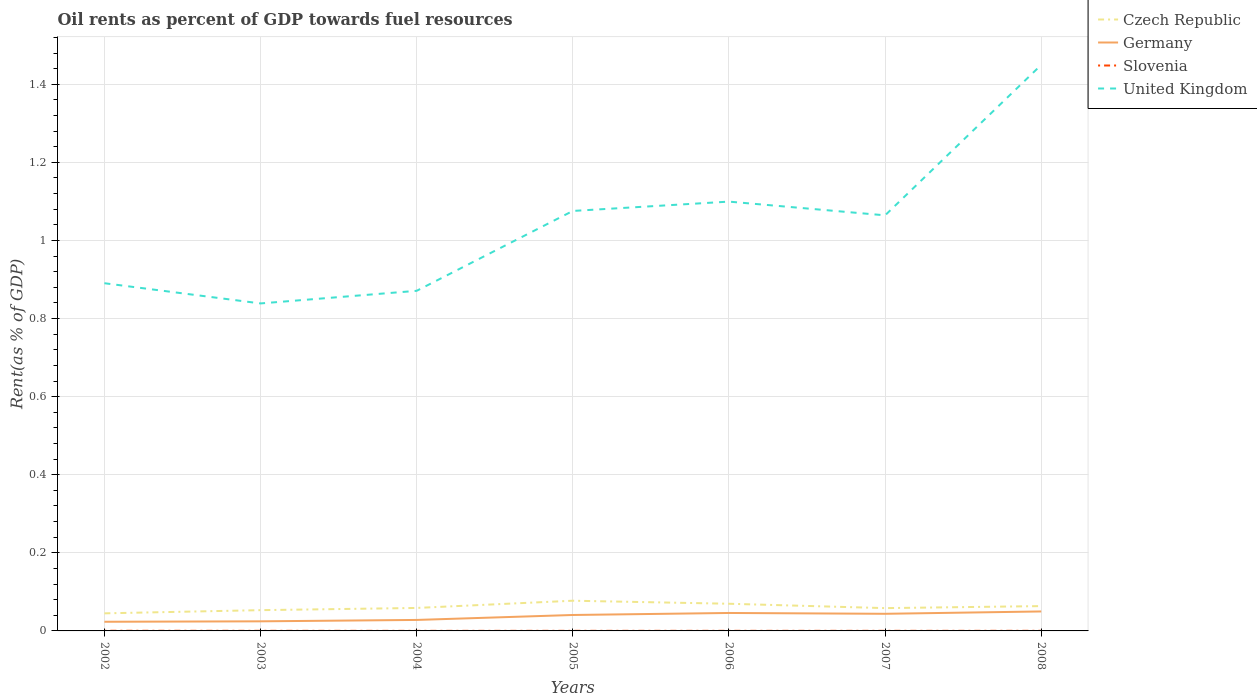How many different coloured lines are there?
Your answer should be very brief. 4. Across all years, what is the maximum oil rent in Czech Republic?
Keep it short and to the point. 0.05. In which year was the oil rent in United Kingdom maximum?
Offer a terse response. 2003. What is the total oil rent in Germany in the graph?
Ensure brevity in your answer.  -0.02. What is the difference between the highest and the second highest oil rent in United Kingdom?
Provide a short and direct response. 0.61. What is the difference between the highest and the lowest oil rent in Slovenia?
Your response must be concise. 3. Is the oil rent in Czech Republic strictly greater than the oil rent in Germany over the years?
Make the answer very short. No. How many lines are there?
Provide a short and direct response. 4. How many years are there in the graph?
Keep it short and to the point. 7. Are the values on the major ticks of Y-axis written in scientific E-notation?
Your answer should be compact. No. Does the graph contain any zero values?
Your response must be concise. No. Does the graph contain grids?
Give a very brief answer. Yes. What is the title of the graph?
Give a very brief answer. Oil rents as percent of GDP towards fuel resources. Does "Luxembourg" appear as one of the legend labels in the graph?
Offer a terse response. No. What is the label or title of the X-axis?
Keep it short and to the point. Years. What is the label or title of the Y-axis?
Give a very brief answer. Rent(as % of GDP). What is the Rent(as % of GDP) of Czech Republic in 2002?
Provide a short and direct response. 0.05. What is the Rent(as % of GDP) in Germany in 2002?
Provide a succinct answer. 0.02. What is the Rent(as % of GDP) of Slovenia in 2002?
Give a very brief answer. 0. What is the Rent(as % of GDP) in United Kingdom in 2002?
Ensure brevity in your answer.  0.89. What is the Rent(as % of GDP) of Czech Republic in 2003?
Give a very brief answer. 0.05. What is the Rent(as % of GDP) in Germany in 2003?
Give a very brief answer. 0.02. What is the Rent(as % of GDP) in Slovenia in 2003?
Provide a succinct answer. 0. What is the Rent(as % of GDP) of United Kingdom in 2003?
Your response must be concise. 0.84. What is the Rent(as % of GDP) in Czech Republic in 2004?
Provide a succinct answer. 0.06. What is the Rent(as % of GDP) in Germany in 2004?
Offer a terse response. 0.03. What is the Rent(as % of GDP) of Slovenia in 2004?
Offer a terse response. 0. What is the Rent(as % of GDP) of United Kingdom in 2004?
Your answer should be very brief. 0.87. What is the Rent(as % of GDP) of Czech Republic in 2005?
Offer a very short reply. 0.08. What is the Rent(as % of GDP) of Germany in 2005?
Offer a terse response. 0.04. What is the Rent(as % of GDP) in Slovenia in 2005?
Offer a very short reply. 0. What is the Rent(as % of GDP) of United Kingdom in 2005?
Make the answer very short. 1.08. What is the Rent(as % of GDP) in Czech Republic in 2006?
Ensure brevity in your answer.  0.07. What is the Rent(as % of GDP) in Germany in 2006?
Give a very brief answer. 0.05. What is the Rent(as % of GDP) of Slovenia in 2006?
Your response must be concise. 0. What is the Rent(as % of GDP) of United Kingdom in 2006?
Provide a short and direct response. 1.1. What is the Rent(as % of GDP) in Czech Republic in 2007?
Make the answer very short. 0.06. What is the Rent(as % of GDP) of Germany in 2007?
Ensure brevity in your answer.  0.04. What is the Rent(as % of GDP) in Slovenia in 2007?
Your answer should be compact. 0. What is the Rent(as % of GDP) in United Kingdom in 2007?
Your answer should be very brief. 1.06. What is the Rent(as % of GDP) of Czech Republic in 2008?
Your response must be concise. 0.06. What is the Rent(as % of GDP) in Germany in 2008?
Provide a short and direct response. 0.05. What is the Rent(as % of GDP) of Slovenia in 2008?
Provide a short and direct response. 0. What is the Rent(as % of GDP) of United Kingdom in 2008?
Make the answer very short. 1.45. Across all years, what is the maximum Rent(as % of GDP) of Czech Republic?
Keep it short and to the point. 0.08. Across all years, what is the maximum Rent(as % of GDP) of Germany?
Provide a short and direct response. 0.05. Across all years, what is the maximum Rent(as % of GDP) in Slovenia?
Offer a terse response. 0. Across all years, what is the maximum Rent(as % of GDP) in United Kingdom?
Your response must be concise. 1.45. Across all years, what is the minimum Rent(as % of GDP) of Czech Republic?
Your answer should be very brief. 0.05. Across all years, what is the minimum Rent(as % of GDP) of Germany?
Offer a very short reply. 0.02. Across all years, what is the minimum Rent(as % of GDP) of Slovenia?
Ensure brevity in your answer.  0. Across all years, what is the minimum Rent(as % of GDP) of United Kingdom?
Your response must be concise. 0.84. What is the total Rent(as % of GDP) in Czech Republic in the graph?
Provide a succinct answer. 0.43. What is the total Rent(as % of GDP) of Germany in the graph?
Give a very brief answer. 0.26. What is the total Rent(as % of GDP) in Slovenia in the graph?
Your response must be concise. 0. What is the total Rent(as % of GDP) of United Kingdom in the graph?
Ensure brevity in your answer.  7.29. What is the difference between the Rent(as % of GDP) of Czech Republic in 2002 and that in 2003?
Offer a terse response. -0.01. What is the difference between the Rent(as % of GDP) of Germany in 2002 and that in 2003?
Offer a very short reply. -0. What is the difference between the Rent(as % of GDP) in United Kingdom in 2002 and that in 2003?
Your response must be concise. 0.05. What is the difference between the Rent(as % of GDP) in Czech Republic in 2002 and that in 2004?
Offer a terse response. -0.01. What is the difference between the Rent(as % of GDP) in Germany in 2002 and that in 2004?
Give a very brief answer. -0. What is the difference between the Rent(as % of GDP) in Slovenia in 2002 and that in 2004?
Give a very brief answer. 0. What is the difference between the Rent(as % of GDP) of United Kingdom in 2002 and that in 2004?
Keep it short and to the point. 0.02. What is the difference between the Rent(as % of GDP) of Czech Republic in 2002 and that in 2005?
Keep it short and to the point. -0.03. What is the difference between the Rent(as % of GDP) of Germany in 2002 and that in 2005?
Ensure brevity in your answer.  -0.02. What is the difference between the Rent(as % of GDP) of Slovenia in 2002 and that in 2005?
Keep it short and to the point. 0. What is the difference between the Rent(as % of GDP) of United Kingdom in 2002 and that in 2005?
Your response must be concise. -0.19. What is the difference between the Rent(as % of GDP) in Czech Republic in 2002 and that in 2006?
Ensure brevity in your answer.  -0.02. What is the difference between the Rent(as % of GDP) of Germany in 2002 and that in 2006?
Offer a very short reply. -0.02. What is the difference between the Rent(as % of GDP) of United Kingdom in 2002 and that in 2006?
Your answer should be compact. -0.21. What is the difference between the Rent(as % of GDP) of Czech Republic in 2002 and that in 2007?
Offer a terse response. -0.01. What is the difference between the Rent(as % of GDP) of Germany in 2002 and that in 2007?
Offer a very short reply. -0.02. What is the difference between the Rent(as % of GDP) in United Kingdom in 2002 and that in 2007?
Your answer should be compact. -0.17. What is the difference between the Rent(as % of GDP) in Czech Republic in 2002 and that in 2008?
Offer a terse response. -0.02. What is the difference between the Rent(as % of GDP) in Germany in 2002 and that in 2008?
Ensure brevity in your answer.  -0.03. What is the difference between the Rent(as % of GDP) in United Kingdom in 2002 and that in 2008?
Offer a very short reply. -0.56. What is the difference between the Rent(as % of GDP) of Czech Republic in 2003 and that in 2004?
Offer a very short reply. -0.01. What is the difference between the Rent(as % of GDP) in Germany in 2003 and that in 2004?
Your answer should be very brief. -0. What is the difference between the Rent(as % of GDP) of United Kingdom in 2003 and that in 2004?
Offer a terse response. -0.03. What is the difference between the Rent(as % of GDP) of Czech Republic in 2003 and that in 2005?
Your answer should be compact. -0.02. What is the difference between the Rent(as % of GDP) of Germany in 2003 and that in 2005?
Ensure brevity in your answer.  -0.02. What is the difference between the Rent(as % of GDP) in United Kingdom in 2003 and that in 2005?
Provide a short and direct response. -0.24. What is the difference between the Rent(as % of GDP) of Czech Republic in 2003 and that in 2006?
Provide a short and direct response. -0.02. What is the difference between the Rent(as % of GDP) in Germany in 2003 and that in 2006?
Make the answer very short. -0.02. What is the difference between the Rent(as % of GDP) of Slovenia in 2003 and that in 2006?
Your answer should be compact. 0. What is the difference between the Rent(as % of GDP) of United Kingdom in 2003 and that in 2006?
Keep it short and to the point. -0.26. What is the difference between the Rent(as % of GDP) of Czech Republic in 2003 and that in 2007?
Provide a succinct answer. -0.01. What is the difference between the Rent(as % of GDP) in Germany in 2003 and that in 2007?
Provide a short and direct response. -0.02. What is the difference between the Rent(as % of GDP) of United Kingdom in 2003 and that in 2007?
Ensure brevity in your answer.  -0.23. What is the difference between the Rent(as % of GDP) of Czech Republic in 2003 and that in 2008?
Your answer should be very brief. -0.01. What is the difference between the Rent(as % of GDP) in Germany in 2003 and that in 2008?
Keep it short and to the point. -0.03. What is the difference between the Rent(as % of GDP) of United Kingdom in 2003 and that in 2008?
Ensure brevity in your answer.  -0.61. What is the difference between the Rent(as % of GDP) of Czech Republic in 2004 and that in 2005?
Provide a succinct answer. -0.02. What is the difference between the Rent(as % of GDP) of Germany in 2004 and that in 2005?
Make the answer very short. -0.01. What is the difference between the Rent(as % of GDP) in United Kingdom in 2004 and that in 2005?
Give a very brief answer. -0.2. What is the difference between the Rent(as % of GDP) of Czech Republic in 2004 and that in 2006?
Make the answer very short. -0.01. What is the difference between the Rent(as % of GDP) of Germany in 2004 and that in 2006?
Offer a terse response. -0.02. What is the difference between the Rent(as % of GDP) in Slovenia in 2004 and that in 2006?
Keep it short and to the point. -0. What is the difference between the Rent(as % of GDP) in United Kingdom in 2004 and that in 2006?
Make the answer very short. -0.23. What is the difference between the Rent(as % of GDP) in Germany in 2004 and that in 2007?
Ensure brevity in your answer.  -0.02. What is the difference between the Rent(as % of GDP) of Slovenia in 2004 and that in 2007?
Offer a very short reply. -0. What is the difference between the Rent(as % of GDP) of United Kingdom in 2004 and that in 2007?
Provide a short and direct response. -0.19. What is the difference between the Rent(as % of GDP) in Czech Republic in 2004 and that in 2008?
Ensure brevity in your answer.  -0. What is the difference between the Rent(as % of GDP) of Germany in 2004 and that in 2008?
Provide a short and direct response. -0.02. What is the difference between the Rent(as % of GDP) in Slovenia in 2004 and that in 2008?
Your response must be concise. -0. What is the difference between the Rent(as % of GDP) in United Kingdom in 2004 and that in 2008?
Your answer should be very brief. -0.58. What is the difference between the Rent(as % of GDP) in Czech Republic in 2005 and that in 2006?
Give a very brief answer. 0.01. What is the difference between the Rent(as % of GDP) of Germany in 2005 and that in 2006?
Offer a very short reply. -0.01. What is the difference between the Rent(as % of GDP) of Slovenia in 2005 and that in 2006?
Offer a terse response. -0. What is the difference between the Rent(as % of GDP) in United Kingdom in 2005 and that in 2006?
Your answer should be very brief. -0.02. What is the difference between the Rent(as % of GDP) in Czech Republic in 2005 and that in 2007?
Offer a very short reply. 0.02. What is the difference between the Rent(as % of GDP) of Germany in 2005 and that in 2007?
Provide a succinct answer. -0. What is the difference between the Rent(as % of GDP) in Slovenia in 2005 and that in 2007?
Offer a very short reply. -0. What is the difference between the Rent(as % of GDP) of United Kingdom in 2005 and that in 2007?
Your response must be concise. 0.01. What is the difference between the Rent(as % of GDP) of Czech Republic in 2005 and that in 2008?
Give a very brief answer. 0.01. What is the difference between the Rent(as % of GDP) in Germany in 2005 and that in 2008?
Give a very brief answer. -0.01. What is the difference between the Rent(as % of GDP) in United Kingdom in 2005 and that in 2008?
Your response must be concise. -0.37. What is the difference between the Rent(as % of GDP) of Czech Republic in 2006 and that in 2007?
Keep it short and to the point. 0.01. What is the difference between the Rent(as % of GDP) of Germany in 2006 and that in 2007?
Ensure brevity in your answer.  0. What is the difference between the Rent(as % of GDP) of United Kingdom in 2006 and that in 2007?
Make the answer very short. 0.04. What is the difference between the Rent(as % of GDP) of Czech Republic in 2006 and that in 2008?
Ensure brevity in your answer.  0.01. What is the difference between the Rent(as % of GDP) of Germany in 2006 and that in 2008?
Your response must be concise. -0. What is the difference between the Rent(as % of GDP) of United Kingdom in 2006 and that in 2008?
Give a very brief answer. -0.35. What is the difference between the Rent(as % of GDP) of Czech Republic in 2007 and that in 2008?
Your response must be concise. -0.01. What is the difference between the Rent(as % of GDP) in Germany in 2007 and that in 2008?
Offer a very short reply. -0.01. What is the difference between the Rent(as % of GDP) in United Kingdom in 2007 and that in 2008?
Make the answer very short. -0.39. What is the difference between the Rent(as % of GDP) of Czech Republic in 2002 and the Rent(as % of GDP) of Germany in 2003?
Your response must be concise. 0.02. What is the difference between the Rent(as % of GDP) of Czech Republic in 2002 and the Rent(as % of GDP) of Slovenia in 2003?
Give a very brief answer. 0.04. What is the difference between the Rent(as % of GDP) of Czech Republic in 2002 and the Rent(as % of GDP) of United Kingdom in 2003?
Give a very brief answer. -0.79. What is the difference between the Rent(as % of GDP) in Germany in 2002 and the Rent(as % of GDP) in Slovenia in 2003?
Your response must be concise. 0.02. What is the difference between the Rent(as % of GDP) in Germany in 2002 and the Rent(as % of GDP) in United Kingdom in 2003?
Ensure brevity in your answer.  -0.82. What is the difference between the Rent(as % of GDP) in Slovenia in 2002 and the Rent(as % of GDP) in United Kingdom in 2003?
Keep it short and to the point. -0.84. What is the difference between the Rent(as % of GDP) of Czech Republic in 2002 and the Rent(as % of GDP) of Germany in 2004?
Your response must be concise. 0.02. What is the difference between the Rent(as % of GDP) in Czech Republic in 2002 and the Rent(as % of GDP) in Slovenia in 2004?
Make the answer very short. 0.04. What is the difference between the Rent(as % of GDP) in Czech Republic in 2002 and the Rent(as % of GDP) in United Kingdom in 2004?
Offer a terse response. -0.83. What is the difference between the Rent(as % of GDP) of Germany in 2002 and the Rent(as % of GDP) of Slovenia in 2004?
Provide a short and direct response. 0.02. What is the difference between the Rent(as % of GDP) of Germany in 2002 and the Rent(as % of GDP) of United Kingdom in 2004?
Keep it short and to the point. -0.85. What is the difference between the Rent(as % of GDP) of Slovenia in 2002 and the Rent(as % of GDP) of United Kingdom in 2004?
Offer a terse response. -0.87. What is the difference between the Rent(as % of GDP) in Czech Republic in 2002 and the Rent(as % of GDP) in Germany in 2005?
Offer a terse response. 0. What is the difference between the Rent(as % of GDP) in Czech Republic in 2002 and the Rent(as % of GDP) in Slovenia in 2005?
Keep it short and to the point. 0.04. What is the difference between the Rent(as % of GDP) in Czech Republic in 2002 and the Rent(as % of GDP) in United Kingdom in 2005?
Provide a succinct answer. -1.03. What is the difference between the Rent(as % of GDP) in Germany in 2002 and the Rent(as % of GDP) in Slovenia in 2005?
Your response must be concise. 0.02. What is the difference between the Rent(as % of GDP) of Germany in 2002 and the Rent(as % of GDP) of United Kingdom in 2005?
Keep it short and to the point. -1.05. What is the difference between the Rent(as % of GDP) of Slovenia in 2002 and the Rent(as % of GDP) of United Kingdom in 2005?
Provide a short and direct response. -1.08. What is the difference between the Rent(as % of GDP) of Czech Republic in 2002 and the Rent(as % of GDP) of Germany in 2006?
Your answer should be compact. -0. What is the difference between the Rent(as % of GDP) in Czech Republic in 2002 and the Rent(as % of GDP) in Slovenia in 2006?
Give a very brief answer. 0.04. What is the difference between the Rent(as % of GDP) in Czech Republic in 2002 and the Rent(as % of GDP) in United Kingdom in 2006?
Keep it short and to the point. -1.05. What is the difference between the Rent(as % of GDP) in Germany in 2002 and the Rent(as % of GDP) in Slovenia in 2006?
Offer a very short reply. 0.02. What is the difference between the Rent(as % of GDP) of Germany in 2002 and the Rent(as % of GDP) of United Kingdom in 2006?
Offer a very short reply. -1.08. What is the difference between the Rent(as % of GDP) in Slovenia in 2002 and the Rent(as % of GDP) in United Kingdom in 2006?
Your answer should be very brief. -1.1. What is the difference between the Rent(as % of GDP) in Czech Republic in 2002 and the Rent(as % of GDP) in Germany in 2007?
Make the answer very short. 0. What is the difference between the Rent(as % of GDP) of Czech Republic in 2002 and the Rent(as % of GDP) of Slovenia in 2007?
Make the answer very short. 0.04. What is the difference between the Rent(as % of GDP) of Czech Republic in 2002 and the Rent(as % of GDP) of United Kingdom in 2007?
Provide a short and direct response. -1.02. What is the difference between the Rent(as % of GDP) in Germany in 2002 and the Rent(as % of GDP) in Slovenia in 2007?
Keep it short and to the point. 0.02. What is the difference between the Rent(as % of GDP) in Germany in 2002 and the Rent(as % of GDP) in United Kingdom in 2007?
Ensure brevity in your answer.  -1.04. What is the difference between the Rent(as % of GDP) in Slovenia in 2002 and the Rent(as % of GDP) in United Kingdom in 2007?
Offer a terse response. -1.06. What is the difference between the Rent(as % of GDP) in Czech Republic in 2002 and the Rent(as % of GDP) in Germany in 2008?
Your answer should be very brief. -0. What is the difference between the Rent(as % of GDP) in Czech Republic in 2002 and the Rent(as % of GDP) in Slovenia in 2008?
Ensure brevity in your answer.  0.04. What is the difference between the Rent(as % of GDP) in Czech Republic in 2002 and the Rent(as % of GDP) in United Kingdom in 2008?
Your answer should be compact. -1.4. What is the difference between the Rent(as % of GDP) in Germany in 2002 and the Rent(as % of GDP) in Slovenia in 2008?
Your answer should be very brief. 0.02. What is the difference between the Rent(as % of GDP) in Germany in 2002 and the Rent(as % of GDP) in United Kingdom in 2008?
Give a very brief answer. -1.43. What is the difference between the Rent(as % of GDP) of Slovenia in 2002 and the Rent(as % of GDP) of United Kingdom in 2008?
Ensure brevity in your answer.  -1.45. What is the difference between the Rent(as % of GDP) in Czech Republic in 2003 and the Rent(as % of GDP) in Germany in 2004?
Your answer should be very brief. 0.03. What is the difference between the Rent(as % of GDP) of Czech Republic in 2003 and the Rent(as % of GDP) of Slovenia in 2004?
Provide a succinct answer. 0.05. What is the difference between the Rent(as % of GDP) in Czech Republic in 2003 and the Rent(as % of GDP) in United Kingdom in 2004?
Your answer should be compact. -0.82. What is the difference between the Rent(as % of GDP) in Germany in 2003 and the Rent(as % of GDP) in Slovenia in 2004?
Provide a succinct answer. 0.02. What is the difference between the Rent(as % of GDP) of Germany in 2003 and the Rent(as % of GDP) of United Kingdom in 2004?
Your answer should be compact. -0.85. What is the difference between the Rent(as % of GDP) of Slovenia in 2003 and the Rent(as % of GDP) of United Kingdom in 2004?
Your answer should be compact. -0.87. What is the difference between the Rent(as % of GDP) in Czech Republic in 2003 and the Rent(as % of GDP) in Germany in 2005?
Offer a very short reply. 0.01. What is the difference between the Rent(as % of GDP) of Czech Republic in 2003 and the Rent(as % of GDP) of Slovenia in 2005?
Ensure brevity in your answer.  0.05. What is the difference between the Rent(as % of GDP) of Czech Republic in 2003 and the Rent(as % of GDP) of United Kingdom in 2005?
Your answer should be compact. -1.02. What is the difference between the Rent(as % of GDP) in Germany in 2003 and the Rent(as % of GDP) in Slovenia in 2005?
Your answer should be very brief. 0.02. What is the difference between the Rent(as % of GDP) in Germany in 2003 and the Rent(as % of GDP) in United Kingdom in 2005?
Make the answer very short. -1.05. What is the difference between the Rent(as % of GDP) in Slovenia in 2003 and the Rent(as % of GDP) in United Kingdom in 2005?
Keep it short and to the point. -1.08. What is the difference between the Rent(as % of GDP) of Czech Republic in 2003 and the Rent(as % of GDP) of Germany in 2006?
Your answer should be compact. 0.01. What is the difference between the Rent(as % of GDP) in Czech Republic in 2003 and the Rent(as % of GDP) in Slovenia in 2006?
Ensure brevity in your answer.  0.05. What is the difference between the Rent(as % of GDP) of Czech Republic in 2003 and the Rent(as % of GDP) of United Kingdom in 2006?
Provide a short and direct response. -1.05. What is the difference between the Rent(as % of GDP) in Germany in 2003 and the Rent(as % of GDP) in Slovenia in 2006?
Offer a terse response. 0.02. What is the difference between the Rent(as % of GDP) in Germany in 2003 and the Rent(as % of GDP) in United Kingdom in 2006?
Your answer should be very brief. -1.07. What is the difference between the Rent(as % of GDP) in Slovenia in 2003 and the Rent(as % of GDP) in United Kingdom in 2006?
Give a very brief answer. -1.1. What is the difference between the Rent(as % of GDP) in Czech Republic in 2003 and the Rent(as % of GDP) in Germany in 2007?
Provide a succinct answer. 0.01. What is the difference between the Rent(as % of GDP) in Czech Republic in 2003 and the Rent(as % of GDP) in Slovenia in 2007?
Offer a very short reply. 0.05. What is the difference between the Rent(as % of GDP) of Czech Republic in 2003 and the Rent(as % of GDP) of United Kingdom in 2007?
Your answer should be very brief. -1.01. What is the difference between the Rent(as % of GDP) in Germany in 2003 and the Rent(as % of GDP) in Slovenia in 2007?
Your answer should be compact. 0.02. What is the difference between the Rent(as % of GDP) in Germany in 2003 and the Rent(as % of GDP) in United Kingdom in 2007?
Your response must be concise. -1.04. What is the difference between the Rent(as % of GDP) in Slovenia in 2003 and the Rent(as % of GDP) in United Kingdom in 2007?
Your response must be concise. -1.06. What is the difference between the Rent(as % of GDP) in Czech Republic in 2003 and the Rent(as % of GDP) in Germany in 2008?
Provide a succinct answer. 0. What is the difference between the Rent(as % of GDP) of Czech Republic in 2003 and the Rent(as % of GDP) of Slovenia in 2008?
Provide a short and direct response. 0.05. What is the difference between the Rent(as % of GDP) in Czech Republic in 2003 and the Rent(as % of GDP) in United Kingdom in 2008?
Offer a terse response. -1.4. What is the difference between the Rent(as % of GDP) in Germany in 2003 and the Rent(as % of GDP) in Slovenia in 2008?
Your answer should be compact. 0.02. What is the difference between the Rent(as % of GDP) of Germany in 2003 and the Rent(as % of GDP) of United Kingdom in 2008?
Offer a terse response. -1.43. What is the difference between the Rent(as % of GDP) in Slovenia in 2003 and the Rent(as % of GDP) in United Kingdom in 2008?
Give a very brief answer. -1.45. What is the difference between the Rent(as % of GDP) of Czech Republic in 2004 and the Rent(as % of GDP) of Germany in 2005?
Offer a terse response. 0.02. What is the difference between the Rent(as % of GDP) of Czech Republic in 2004 and the Rent(as % of GDP) of Slovenia in 2005?
Ensure brevity in your answer.  0.06. What is the difference between the Rent(as % of GDP) in Czech Republic in 2004 and the Rent(as % of GDP) in United Kingdom in 2005?
Keep it short and to the point. -1.02. What is the difference between the Rent(as % of GDP) of Germany in 2004 and the Rent(as % of GDP) of Slovenia in 2005?
Ensure brevity in your answer.  0.03. What is the difference between the Rent(as % of GDP) of Germany in 2004 and the Rent(as % of GDP) of United Kingdom in 2005?
Ensure brevity in your answer.  -1.05. What is the difference between the Rent(as % of GDP) of Slovenia in 2004 and the Rent(as % of GDP) of United Kingdom in 2005?
Provide a short and direct response. -1.08. What is the difference between the Rent(as % of GDP) of Czech Republic in 2004 and the Rent(as % of GDP) of Germany in 2006?
Offer a terse response. 0.01. What is the difference between the Rent(as % of GDP) of Czech Republic in 2004 and the Rent(as % of GDP) of Slovenia in 2006?
Ensure brevity in your answer.  0.06. What is the difference between the Rent(as % of GDP) of Czech Republic in 2004 and the Rent(as % of GDP) of United Kingdom in 2006?
Offer a terse response. -1.04. What is the difference between the Rent(as % of GDP) of Germany in 2004 and the Rent(as % of GDP) of Slovenia in 2006?
Ensure brevity in your answer.  0.03. What is the difference between the Rent(as % of GDP) in Germany in 2004 and the Rent(as % of GDP) in United Kingdom in 2006?
Provide a short and direct response. -1.07. What is the difference between the Rent(as % of GDP) of Slovenia in 2004 and the Rent(as % of GDP) of United Kingdom in 2006?
Provide a short and direct response. -1.1. What is the difference between the Rent(as % of GDP) of Czech Republic in 2004 and the Rent(as % of GDP) of Germany in 2007?
Offer a terse response. 0.01. What is the difference between the Rent(as % of GDP) of Czech Republic in 2004 and the Rent(as % of GDP) of Slovenia in 2007?
Provide a succinct answer. 0.06. What is the difference between the Rent(as % of GDP) in Czech Republic in 2004 and the Rent(as % of GDP) in United Kingdom in 2007?
Offer a terse response. -1.01. What is the difference between the Rent(as % of GDP) in Germany in 2004 and the Rent(as % of GDP) in Slovenia in 2007?
Give a very brief answer. 0.03. What is the difference between the Rent(as % of GDP) in Germany in 2004 and the Rent(as % of GDP) in United Kingdom in 2007?
Offer a terse response. -1.04. What is the difference between the Rent(as % of GDP) of Slovenia in 2004 and the Rent(as % of GDP) of United Kingdom in 2007?
Make the answer very short. -1.06. What is the difference between the Rent(as % of GDP) of Czech Republic in 2004 and the Rent(as % of GDP) of Germany in 2008?
Offer a very short reply. 0.01. What is the difference between the Rent(as % of GDP) of Czech Republic in 2004 and the Rent(as % of GDP) of Slovenia in 2008?
Offer a very short reply. 0.06. What is the difference between the Rent(as % of GDP) in Czech Republic in 2004 and the Rent(as % of GDP) in United Kingdom in 2008?
Offer a very short reply. -1.39. What is the difference between the Rent(as % of GDP) of Germany in 2004 and the Rent(as % of GDP) of Slovenia in 2008?
Offer a terse response. 0.03. What is the difference between the Rent(as % of GDP) of Germany in 2004 and the Rent(as % of GDP) of United Kingdom in 2008?
Your answer should be very brief. -1.42. What is the difference between the Rent(as % of GDP) of Slovenia in 2004 and the Rent(as % of GDP) of United Kingdom in 2008?
Offer a terse response. -1.45. What is the difference between the Rent(as % of GDP) in Czech Republic in 2005 and the Rent(as % of GDP) in Germany in 2006?
Your answer should be very brief. 0.03. What is the difference between the Rent(as % of GDP) of Czech Republic in 2005 and the Rent(as % of GDP) of Slovenia in 2006?
Your response must be concise. 0.08. What is the difference between the Rent(as % of GDP) in Czech Republic in 2005 and the Rent(as % of GDP) in United Kingdom in 2006?
Your answer should be compact. -1.02. What is the difference between the Rent(as % of GDP) of Germany in 2005 and the Rent(as % of GDP) of Slovenia in 2006?
Keep it short and to the point. 0.04. What is the difference between the Rent(as % of GDP) of Germany in 2005 and the Rent(as % of GDP) of United Kingdom in 2006?
Make the answer very short. -1.06. What is the difference between the Rent(as % of GDP) in Slovenia in 2005 and the Rent(as % of GDP) in United Kingdom in 2006?
Provide a short and direct response. -1.1. What is the difference between the Rent(as % of GDP) of Czech Republic in 2005 and the Rent(as % of GDP) of Germany in 2007?
Offer a terse response. 0.03. What is the difference between the Rent(as % of GDP) in Czech Republic in 2005 and the Rent(as % of GDP) in Slovenia in 2007?
Provide a short and direct response. 0.08. What is the difference between the Rent(as % of GDP) in Czech Republic in 2005 and the Rent(as % of GDP) in United Kingdom in 2007?
Your answer should be compact. -0.99. What is the difference between the Rent(as % of GDP) of Germany in 2005 and the Rent(as % of GDP) of Slovenia in 2007?
Ensure brevity in your answer.  0.04. What is the difference between the Rent(as % of GDP) in Germany in 2005 and the Rent(as % of GDP) in United Kingdom in 2007?
Provide a succinct answer. -1.02. What is the difference between the Rent(as % of GDP) in Slovenia in 2005 and the Rent(as % of GDP) in United Kingdom in 2007?
Provide a short and direct response. -1.06. What is the difference between the Rent(as % of GDP) of Czech Republic in 2005 and the Rent(as % of GDP) of Germany in 2008?
Provide a short and direct response. 0.03. What is the difference between the Rent(as % of GDP) in Czech Republic in 2005 and the Rent(as % of GDP) in Slovenia in 2008?
Offer a terse response. 0.08. What is the difference between the Rent(as % of GDP) of Czech Republic in 2005 and the Rent(as % of GDP) of United Kingdom in 2008?
Keep it short and to the point. -1.37. What is the difference between the Rent(as % of GDP) of Germany in 2005 and the Rent(as % of GDP) of Slovenia in 2008?
Offer a terse response. 0.04. What is the difference between the Rent(as % of GDP) of Germany in 2005 and the Rent(as % of GDP) of United Kingdom in 2008?
Give a very brief answer. -1.41. What is the difference between the Rent(as % of GDP) in Slovenia in 2005 and the Rent(as % of GDP) in United Kingdom in 2008?
Provide a succinct answer. -1.45. What is the difference between the Rent(as % of GDP) in Czech Republic in 2006 and the Rent(as % of GDP) in Germany in 2007?
Ensure brevity in your answer.  0.03. What is the difference between the Rent(as % of GDP) in Czech Republic in 2006 and the Rent(as % of GDP) in Slovenia in 2007?
Your response must be concise. 0.07. What is the difference between the Rent(as % of GDP) in Czech Republic in 2006 and the Rent(as % of GDP) in United Kingdom in 2007?
Your response must be concise. -0.99. What is the difference between the Rent(as % of GDP) in Germany in 2006 and the Rent(as % of GDP) in Slovenia in 2007?
Keep it short and to the point. 0.05. What is the difference between the Rent(as % of GDP) of Germany in 2006 and the Rent(as % of GDP) of United Kingdom in 2007?
Provide a succinct answer. -1.02. What is the difference between the Rent(as % of GDP) in Slovenia in 2006 and the Rent(as % of GDP) in United Kingdom in 2007?
Keep it short and to the point. -1.06. What is the difference between the Rent(as % of GDP) in Czech Republic in 2006 and the Rent(as % of GDP) in Germany in 2008?
Your answer should be compact. 0.02. What is the difference between the Rent(as % of GDP) of Czech Republic in 2006 and the Rent(as % of GDP) of Slovenia in 2008?
Make the answer very short. 0.07. What is the difference between the Rent(as % of GDP) in Czech Republic in 2006 and the Rent(as % of GDP) in United Kingdom in 2008?
Your answer should be very brief. -1.38. What is the difference between the Rent(as % of GDP) of Germany in 2006 and the Rent(as % of GDP) of Slovenia in 2008?
Ensure brevity in your answer.  0.05. What is the difference between the Rent(as % of GDP) in Germany in 2006 and the Rent(as % of GDP) in United Kingdom in 2008?
Keep it short and to the point. -1.4. What is the difference between the Rent(as % of GDP) of Slovenia in 2006 and the Rent(as % of GDP) of United Kingdom in 2008?
Your answer should be very brief. -1.45. What is the difference between the Rent(as % of GDP) in Czech Republic in 2007 and the Rent(as % of GDP) in Germany in 2008?
Offer a terse response. 0.01. What is the difference between the Rent(as % of GDP) of Czech Republic in 2007 and the Rent(as % of GDP) of Slovenia in 2008?
Keep it short and to the point. 0.06. What is the difference between the Rent(as % of GDP) of Czech Republic in 2007 and the Rent(as % of GDP) of United Kingdom in 2008?
Offer a very short reply. -1.39. What is the difference between the Rent(as % of GDP) of Germany in 2007 and the Rent(as % of GDP) of Slovenia in 2008?
Provide a short and direct response. 0.04. What is the difference between the Rent(as % of GDP) of Germany in 2007 and the Rent(as % of GDP) of United Kingdom in 2008?
Your response must be concise. -1.41. What is the difference between the Rent(as % of GDP) in Slovenia in 2007 and the Rent(as % of GDP) in United Kingdom in 2008?
Provide a succinct answer. -1.45. What is the average Rent(as % of GDP) in Czech Republic per year?
Your answer should be very brief. 0.06. What is the average Rent(as % of GDP) of Germany per year?
Your answer should be compact. 0.04. What is the average Rent(as % of GDP) of Slovenia per year?
Give a very brief answer. 0. What is the average Rent(as % of GDP) of United Kingdom per year?
Your response must be concise. 1.04. In the year 2002, what is the difference between the Rent(as % of GDP) in Czech Republic and Rent(as % of GDP) in Germany?
Offer a very short reply. 0.02. In the year 2002, what is the difference between the Rent(as % of GDP) in Czech Republic and Rent(as % of GDP) in Slovenia?
Your answer should be very brief. 0.04. In the year 2002, what is the difference between the Rent(as % of GDP) in Czech Republic and Rent(as % of GDP) in United Kingdom?
Provide a succinct answer. -0.85. In the year 2002, what is the difference between the Rent(as % of GDP) in Germany and Rent(as % of GDP) in Slovenia?
Provide a short and direct response. 0.02. In the year 2002, what is the difference between the Rent(as % of GDP) in Germany and Rent(as % of GDP) in United Kingdom?
Your response must be concise. -0.87. In the year 2002, what is the difference between the Rent(as % of GDP) of Slovenia and Rent(as % of GDP) of United Kingdom?
Give a very brief answer. -0.89. In the year 2003, what is the difference between the Rent(as % of GDP) in Czech Republic and Rent(as % of GDP) in Germany?
Ensure brevity in your answer.  0.03. In the year 2003, what is the difference between the Rent(as % of GDP) of Czech Republic and Rent(as % of GDP) of Slovenia?
Give a very brief answer. 0.05. In the year 2003, what is the difference between the Rent(as % of GDP) of Czech Republic and Rent(as % of GDP) of United Kingdom?
Give a very brief answer. -0.79. In the year 2003, what is the difference between the Rent(as % of GDP) in Germany and Rent(as % of GDP) in Slovenia?
Give a very brief answer. 0.02. In the year 2003, what is the difference between the Rent(as % of GDP) in Germany and Rent(as % of GDP) in United Kingdom?
Your answer should be compact. -0.81. In the year 2003, what is the difference between the Rent(as % of GDP) in Slovenia and Rent(as % of GDP) in United Kingdom?
Keep it short and to the point. -0.84. In the year 2004, what is the difference between the Rent(as % of GDP) in Czech Republic and Rent(as % of GDP) in Germany?
Offer a very short reply. 0.03. In the year 2004, what is the difference between the Rent(as % of GDP) of Czech Republic and Rent(as % of GDP) of Slovenia?
Offer a very short reply. 0.06. In the year 2004, what is the difference between the Rent(as % of GDP) in Czech Republic and Rent(as % of GDP) in United Kingdom?
Ensure brevity in your answer.  -0.81. In the year 2004, what is the difference between the Rent(as % of GDP) in Germany and Rent(as % of GDP) in Slovenia?
Offer a terse response. 0.03. In the year 2004, what is the difference between the Rent(as % of GDP) in Germany and Rent(as % of GDP) in United Kingdom?
Offer a terse response. -0.84. In the year 2004, what is the difference between the Rent(as % of GDP) of Slovenia and Rent(as % of GDP) of United Kingdom?
Ensure brevity in your answer.  -0.87. In the year 2005, what is the difference between the Rent(as % of GDP) of Czech Republic and Rent(as % of GDP) of Germany?
Your answer should be very brief. 0.04. In the year 2005, what is the difference between the Rent(as % of GDP) of Czech Republic and Rent(as % of GDP) of Slovenia?
Offer a very short reply. 0.08. In the year 2005, what is the difference between the Rent(as % of GDP) in Czech Republic and Rent(as % of GDP) in United Kingdom?
Ensure brevity in your answer.  -1. In the year 2005, what is the difference between the Rent(as % of GDP) in Germany and Rent(as % of GDP) in Slovenia?
Give a very brief answer. 0.04. In the year 2005, what is the difference between the Rent(as % of GDP) of Germany and Rent(as % of GDP) of United Kingdom?
Offer a terse response. -1.03. In the year 2005, what is the difference between the Rent(as % of GDP) in Slovenia and Rent(as % of GDP) in United Kingdom?
Ensure brevity in your answer.  -1.08. In the year 2006, what is the difference between the Rent(as % of GDP) of Czech Republic and Rent(as % of GDP) of Germany?
Ensure brevity in your answer.  0.02. In the year 2006, what is the difference between the Rent(as % of GDP) in Czech Republic and Rent(as % of GDP) in Slovenia?
Offer a very short reply. 0.07. In the year 2006, what is the difference between the Rent(as % of GDP) of Czech Republic and Rent(as % of GDP) of United Kingdom?
Your response must be concise. -1.03. In the year 2006, what is the difference between the Rent(as % of GDP) in Germany and Rent(as % of GDP) in Slovenia?
Offer a terse response. 0.05. In the year 2006, what is the difference between the Rent(as % of GDP) of Germany and Rent(as % of GDP) of United Kingdom?
Provide a succinct answer. -1.05. In the year 2006, what is the difference between the Rent(as % of GDP) in Slovenia and Rent(as % of GDP) in United Kingdom?
Your answer should be very brief. -1.1. In the year 2007, what is the difference between the Rent(as % of GDP) in Czech Republic and Rent(as % of GDP) in Germany?
Ensure brevity in your answer.  0.01. In the year 2007, what is the difference between the Rent(as % of GDP) of Czech Republic and Rent(as % of GDP) of Slovenia?
Ensure brevity in your answer.  0.06. In the year 2007, what is the difference between the Rent(as % of GDP) in Czech Republic and Rent(as % of GDP) in United Kingdom?
Your answer should be very brief. -1.01. In the year 2007, what is the difference between the Rent(as % of GDP) in Germany and Rent(as % of GDP) in Slovenia?
Provide a short and direct response. 0.04. In the year 2007, what is the difference between the Rent(as % of GDP) of Germany and Rent(as % of GDP) of United Kingdom?
Your answer should be compact. -1.02. In the year 2007, what is the difference between the Rent(as % of GDP) in Slovenia and Rent(as % of GDP) in United Kingdom?
Make the answer very short. -1.06. In the year 2008, what is the difference between the Rent(as % of GDP) of Czech Republic and Rent(as % of GDP) of Germany?
Ensure brevity in your answer.  0.01. In the year 2008, what is the difference between the Rent(as % of GDP) of Czech Republic and Rent(as % of GDP) of Slovenia?
Offer a terse response. 0.06. In the year 2008, what is the difference between the Rent(as % of GDP) of Czech Republic and Rent(as % of GDP) of United Kingdom?
Ensure brevity in your answer.  -1.39. In the year 2008, what is the difference between the Rent(as % of GDP) of Germany and Rent(as % of GDP) of Slovenia?
Ensure brevity in your answer.  0.05. In the year 2008, what is the difference between the Rent(as % of GDP) of Germany and Rent(as % of GDP) of United Kingdom?
Ensure brevity in your answer.  -1.4. In the year 2008, what is the difference between the Rent(as % of GDP) in Slovenia and Rent(as % of GDP) in United Kingdom?
Offer a terse response. -1.45. What is the ratio of the Rent(as % of GDP) of Czech Republic in 2002 to that in 2003?
Give a very brief answer. 0.85. What is the ratio of the Rent(as % of GDP) in Germany in 2002 to that in 2003?
Offer a terse response. 0.95. What is the ratio of the Rent(as % of GDP) of Slovenia in 2002 to that in 2003?
Provide a short and direct response. 1.47. What is the ratio of the Rent(as % of GDP) in United Kingdom in 2002 to that in 2003?
Provide a short and direct response. 1.06. What is the ratio of the Rent(as % of GDP) in Czech Republic in 2002 to that in 2004?
Offer a very short reply. 0.77. What is the ratio of the Rent(as % of GDP) in Germany in 2002 to that in 2004?
Keep it short and to the point. 0.83. What is the ratio of the Rent(as % of GDP) of Slovenia in 2002 to that in 2004?
Your answer should be very brief. 2.07. What is the ratio of the Rent(as % of GDP) of United Kingdom in 2002 to that in 2004?
Make the answer very short. 1.02. What is the ratio of the Rent(as % of GDP) of Czech Republic in 2002 to that in 2005?
Your response must be concise. 0.58. What is the ratio of the Rent(as % of GDP) in Germany in 2002 to that in 2005?
Your response must be concise. 0.57. What is the ratio of the Rent(as % of GDP) of Slovenia in 2002 to that in 2005?
Offer a terse response. 1.78. What is the ratio of the Rent(as % of GDP) of United Kingdom in 2002 to that in 2005?
Offer a terse response. 0.83. What is the ratio of the Rent(as % of GDP) in Czech Republic in 2002 to that in 2006?
Offer a very short reply. 0.65. What is the ratio of the Rent(as % of GDP) of Germany in 2002 to that in 2006?
Provide a short and direct response. 0.51. What is the ratio of the Rent(as % of GDP) of Slovenia in 2002 to that in 2006?
Your answer should be compact. 1.6. What is the ratio of the Rent(as % of GDP) of United Kingdom in 2002 to that in 2006?
Provide a short and direct response. 0.81. What is the ratio of the Rent(as % of GDP) in Czech Republic in 2002 to that in 2007?
Your response must be concise. 0.77. What is the ratio of the Rent(as % of GDP) of Germany in 2002 to that in 2007?
Make the answer very short. 0.53. What is the ratio of the Rent(as % of GDP) of Slovenia in 2002 to that in 2007?
Offer a very short reply. 1.77. What is the ratio of the Rent(as % of GDP) of United Kingdom in 2002 to that in 2007?
Ensure brevity in your answer.  0.84. What is the ratio of the Rent(as % of GDP) of Czech Republic in 2002 to that in 2008?
Keep it short and to the point. 0.71. What is the ratio of the Rent(as % of GDP) of Germany in 2002 to that in 2008?
Make the answer very short. 0.47. What is the ratio of the Rent(as % of GDP) in Slovenia in 2002 to that in 2008?
Your response must be concise. 1.48. What is the ratio of the Rent(as % of GDP) of United Kingdom in 2002 to that in 2008?
Your response must be concise. 0.61. What is the ratio of the Rent(as % of GDP) in Czech Republic in 2003 to that in 2004?
Your response must be concise. 0.9. What is the ratio of the Rent(as % of GDP) in Germany in 2003 to that in 2004?
Give a very brief answer. 0.87. What is the ratio of the Rent(as % of GDP) of Slovenia in 2003 to that in 2004?
Give a very brief answer. 1.41. What is the ratio of the Rent(as % of GDP) in United Kingdom in 2003 to that in 2004?
Your response must be concise. 0.96. What is the ratio of the Rent(as % of GDP) in Czech Republic in 2003 to that in 2005?
Keep it short and to the point. 0.69. What is the ratio of the Rent(as % of GDP) of Germany in 2003 to that in 2005?
Ensure brevity in your answer.  0.6. What is the ratio of the Rent(as % of GDP) in Slovenia in 2003 to that in 2005?
Your response must be concise. 1.21. What is the ratio of the Rent(as % of GDP) of United Kingdom in 2003 to that in 2005?
Your response must be concise. 0.78. What is the ratio of the Rent(as % of GDP) in Czech Republic in 2003 to that in 2006?
Your answer should be compact. 0.76. What is the ratio of the Rent(as % of GDP) of Germany in 2003 to that in 2006?
Your answer should be compact. 0.53. What is the ratio of the Rent(as % of GDP) in Slovenia in 2003 to that in 2006?
Ensure brevity in your answer.  1.09. What is the ratio of the Rent(as % of GDP) of United Kingdom in 2003 to that in 2006?
Keep it short and to the point. 0.76. What is the ratio of the Rent(as % of GDP) in Czech Republic in 2003 to that in 2007?
Offer a very short reply. 0.91. What is the ratio of the Rent(as % of GDP) of Germany in 2003 to that in 2007?
Offer a terse response. 0.56. What is the ratio of the Rent(as % of GDP) in Slovenia in 2003 to that in 2007?
Keep it short and to the point. 1.2. What is the ratio of the Rent(as % of GDP) in United Kingdom in 2003 to that in 2007?
Provide a short and direct response. 0.79. What is the ratio of the Rent(as % of GDP) in Czech Republic in 2003 to that in 2008?
Provide a short and direct response. 0.84. What is the ratio of the Rent(as % of GDP) of Germany in 2003 to that in 2008?
Keep it short and to the point. 0.49. What is the ratio of the Rent(as % of GDP) in Slovenia in 2003 to that in 2008?
Offer a very short reply. 1.01. What is the ratio of the Rent(as % of GDP) of United Kingdom in 2003 to that in 2008?
Provide a succinct answer. 0.58. What is the ratio of the Rent(as % of GDP) of Czech Republic in 2004 to that in 2005?
Provide a succinct answer. 0.76. What is the ratio of the Rent(as % of GDP) of Germany in 2004 to that in 2005?
Your answer should be compact. 0.69. What is the ratio of the Rent(as % of GDP) in Slovenia in 2004 to that in 2005?
Make the answer very short. 0.86. What is the ratio of the Rent(as % of GDP) of United Kingdom in 2004 to that in 2005?
Your response must be concise. 0.81. What is the ratio of the Rent(as % of GDP) of Czech Republic in 2004 to that in 2006?
Ensure brevity in your answer.  0.85. What is the ratio of the Rent(as % of GDP) in Germany in 2004 to that in 2006?
Give a very brief answer. 0.61. What is the ratio of the Rent(as % of GDP) of Slovenia in 2004 to that in 2006?
Make the answer very short. 0.78. What is the ratio of the Rent(as % of GDP) of United Kingdom in 2004 to that in 2006?
Ensure brevity in your answer.  0.79. What is the ratio of the Rent(as % of GDP) in Czech Republic in 2004 to that in 2007?
Give a very brief answer. 1.01. What is the ratio of the Rent(as % of GDP) of Germany in 2004 to that in 2007?
Keep it short and to the point. 0.64. What is the ratio of the Rent(as % of GDP) in Slovenia in 2004 to that in 2007?
Make the answer very short. 0.86. What is the ratio of the Rent(as % of GDP) in United Kingdom in 2004 to that in 2007?
Your answer should be compact. 0.82. What is the ratio of the Rent(as % of GDP) of Czech Republic in 2004 to that in 2008?
Provide a short and direct response. 0.93. What is the ratio of the Rent(as % of GDP) of Germany in 2004 to that in 2008?
Your answer should be compact. 0.56. What is the ratio of the Rent(as % of GDP) in Slovenia in 2004 to that in 2008?
Provide a succinct answer. 0.72. What is the ratio of the Rent(as % of GDP) of United Kingdom in 2004 to that in 2008?
Give a very brief answer. 0.6. What is the ratio of the Rent(as % of GDP) of Czech Republic in 2005 to that in 2006?
Your answer should be compact. 1.11. What is the ratio of the Rent(as % of GDP) of Germany in 2005 to that in 2006?
Keep it short and to the point. 0.89. What is the ratio of the Rent(as % of GDP) of Slovenia in 2005 to that in 2006?
Offer a very short reply. 0.9. What is the ratio of the Rent(as % of GDP) in United Kingdom in 2005 to that in 2006?
Your answer should be compact. 0.98. What is the ratio of the Rent(as % of GDP) in Czech Republic in 2005 to that in 2007?
Make the answer very short. 1.32. What is the ratio of the Rent(as % of GDP) of Germany in 2005 to that in 2007?
Your answer should be very brief. 0.93. What is the ratio of the Rent(as % of GDP) of Slovenia in 2005 to that in 2007?
Your answer should be very brief. 0.99. What is the ratio of the Rent(as % of GDP) in United Kingdom in 2005 to that in 2007?
Your answer should be very brief. 1.01. What is the ratio of the Rent(as % of GDP) in Czech Republic in 2005 to that in 2008?
Your answer should be very brief. 1.22. What is the ratio of the Rent(as % of GDP) of Germany in 2005 to that in 2008?
Your answer should be compact. 0.82. What is the ratio of the Rent(as % of GDP) in Slovenia in 2005 to that in 2008?
Your response must be concise. 0.83. What is the ratio of the Rent(as % of GDP) of United Kingdom in 2005 to that in 2008?
Your answer should be compact. 0.74. What is the ratio of the Rent(as % of GDP) in Czech Republic in 2006 to that in 2007?
Provide a short and direct response. 1.19. What is the ratio of the Rent(as % of GDP) in Germany in 2006 to that in 2007?
Make the answer very short. 1.05. What is the ratio of the Rent(as % of GDP) in Slovenia in 2006 to that in 2007?
Make the answer very short. 1.11. What is the ratio of the Rent(as % of GDP) of United Kingdom in 2006 to that in 2007?
Your answer should be compact. 1.03. What is the ratio of the Rent(as % of GDP) in Czech Republic in 2006 to that in 2008?
Make the answer very short. 1.09. What is the ratio of the Rent(as % of GDP) in Germany in 2006 to that in 2008?
Provide a short and direct response. 0.92. What is the ratio of the Rent(as % of GDP) in Slovenia in 2006 to that in 2008?
Offer a terse response. 0.92. What is the ratio of the Rent(as % of GDP) in United Kingdom in 2006 to that in 2008?
Offer a very short reply. 0.76. What is the ratio of the Rent(as % of GDP) of Czech Republic in 2007 to that in 2008?
Ensure brevity in your answer.  0.92. What is the ratio of the Rent(as % of GDP) in Germany in 2007 to that in 2008?
Provide a succinct answer. 0.88. What is the ratio of the Rent(as % of GDP) of Slovenia in 2007 to that in 2008?
Your answer should be compact. 0.84. What is the ratio of the Rent(as % of GDP) of United Kingdom in 2007 to that in 2008?
Your answer should be compact. 0.73. What is the difference between the highest and the second highest Rent(as % of GDP) in Czech Republic?
Offer a terse response. 0.01. What is the difference between the highest and the second highest Rent(as % of GDP) of Germany?
Give a very brief answer. 0. What is the difference between the highest and the second highest Rent(as % of GDP) of Slovenia?
Give a very brief answer. 0. What is the difference between the highest and the second highest Rent(as % of GDP) of United Kingdom?
Provide a succinct answer. 0.35. What is the difference between the highest and the lowest Rent(as % of GDP) of Czech Republic?
Give a very brief answer. 0.03. What is the difference between the highest and the lowest Rent(as % of GDP) of Germany?
Provide a succinct answer. 0.03. What is the difference between the highest and the lowest Rent(as % of GDP) in Slovenia?
Your answer should be compact. 0. What is the difference between the highest and the lowest Rent(as % of GDP) of United Kingdom?
Your answer should be compact. 0.61. 